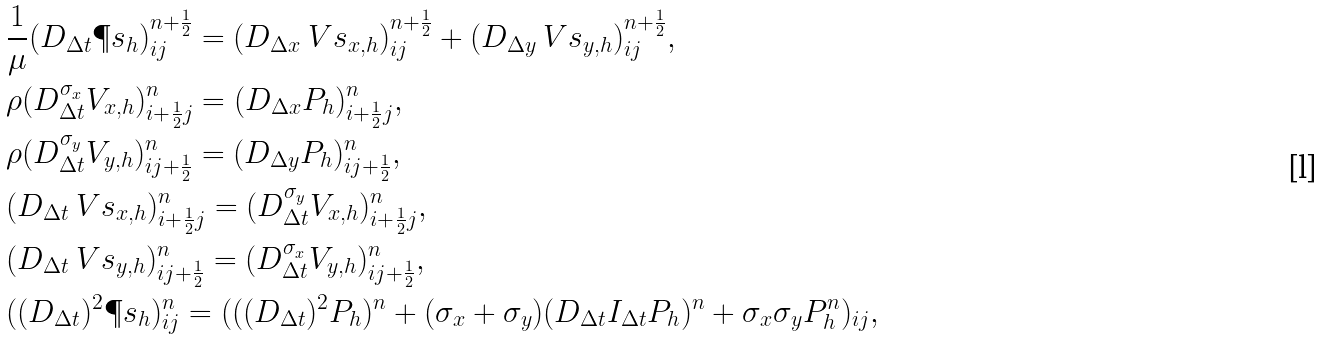<formula> <loc_0><loc_0><loc_500><loc_500>& \frac { 1 } { \mu } ( D _ { \Delta t } \P s _ { h } ) ^ { n + \frac { 1 } { 2 } } _ { i j } = ( D _ { \Delta x } \ V s _ { x , h } ) ^ { n + \frac { 1 } { 2 } } _ { i j } + ( D _ { \Delta y } \ V s _ { y , h } ) ^ { n + \frac { 1 } { 2 } } _ { i j } , \\ & \rho ( D _ { \Delta t } ^ { \sigma _ { x } } V _ { x , h } ) ^ { n } _ { i + \frac { 1 } { 2 } j } = ( D _ { \Delta x } P _ { h } ) ^ { n } _ { i + \frac { 1 } { 2 } j } , \\ & \rho ( D _ { \Delta t } ^ { \sigma _ { y } } V _ { y , h } ) ^ { n } _ { i j + \frac { 1 } { 2 } } = ( D _ { \Delta y } P _ { h } ) ^ { n } _ { i j + \frac { 1 } { 2 } } , \\ & ( D _ { \Delta t } \ V s _ { x , h } ) ^ { n } _ { i + \frac { 1 } { 2 } j } = ( D _ { \Delta t } ^ { \sigma _ { y } } V _ { x , h } ) ^ { n } _ { i + \frac { 1 } { 2 } j } , \\ & ( D _ { \Delta t } \ V s _ { y , h } ) ^ { n } _ { i j + \frac { 1 } { 2 } } = ( D _ { \Delta t } ^ { \sigma _ { x } } V _ { y , h } ) ^ { n } _ { i j + \frac { 1 } { 2 } } , \\ & ( ( D _ { \Delta t } ) ^ { 2 } \P s _ { h } ) ^ { n } _ { i j } = ( ( ( D _ { \Delta t } ) ^ { 2 } P _ { h } ) ^ { n } + ( \sigma _ { x } + \sigma _ { y } ) ( D _ { \Delta t } I _ { \Delta t } { P _ { h } } ) ^ { n } + \sigma _ { x } \sigma _ { y } P _ { h } ^ { n } ) _ { i j } ,</formula> 